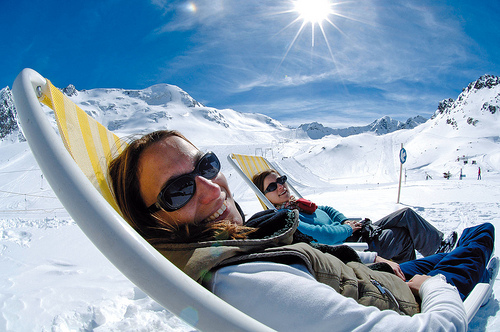<image>
Can you confirm if the women is on the eyeglass? Yes. Looking at the image, I can see the women is positioned on top of the eyeglass, with the eyeglass providing support. 